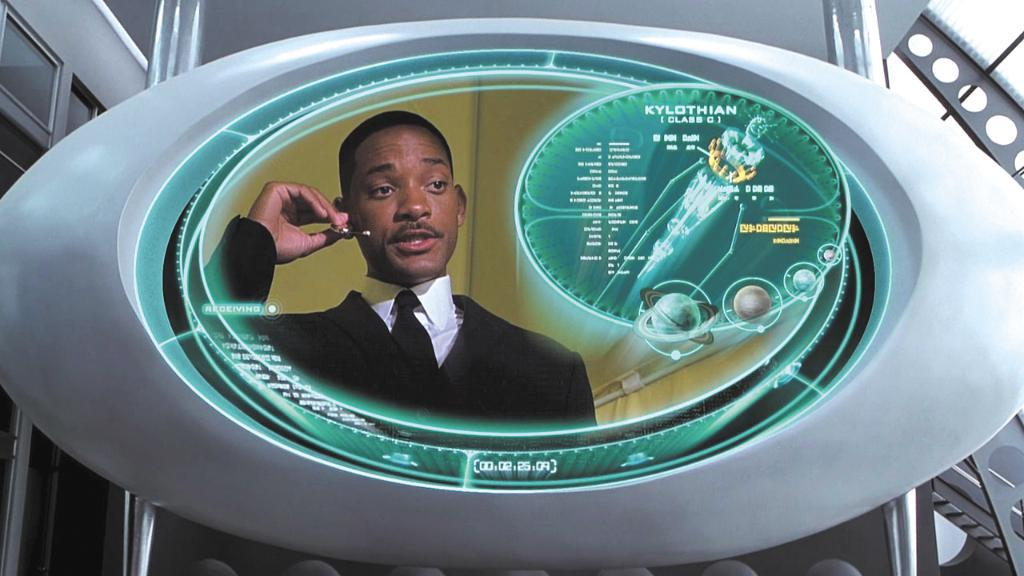What is the main object in the image? There is a screen in the image. What can be seen on the screen? A person with a black and white dress is visible on the screen. What can be seen in the background of the image? There is a building and the sky visible in the background of the image. How many trees can be seen in the image? There are no trees visible in the image; it only features a screen with a person on it, a building, and the sky in the background. 